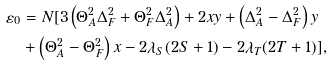<formula> <loc_0><loc_0><loc_500><loc_500>\varepsilon _ { 0 } & = N [ 3 \left ( \Theta _ { A } ^ { 2 } \Delta _ { F } ^ { 2 } + \Theta _ { F } ^ { 2 } \Delta _ { A } ^ { 2 } \right ) + 2 x y + \left ( \Delta _ { A } ^ { 2 } - \Delta _ { F } ^ { 2 } \right ) y \\ & + \left ( \Theta _ { A } ^ { 2 } - \Theta _ { F } ^ { 2 } \right ) x - 2 \lambda _ { S } ( 2 S + 1 ) - 2 \lambda _ { T } ( 2 T + 1 ) ] ,</formula> 